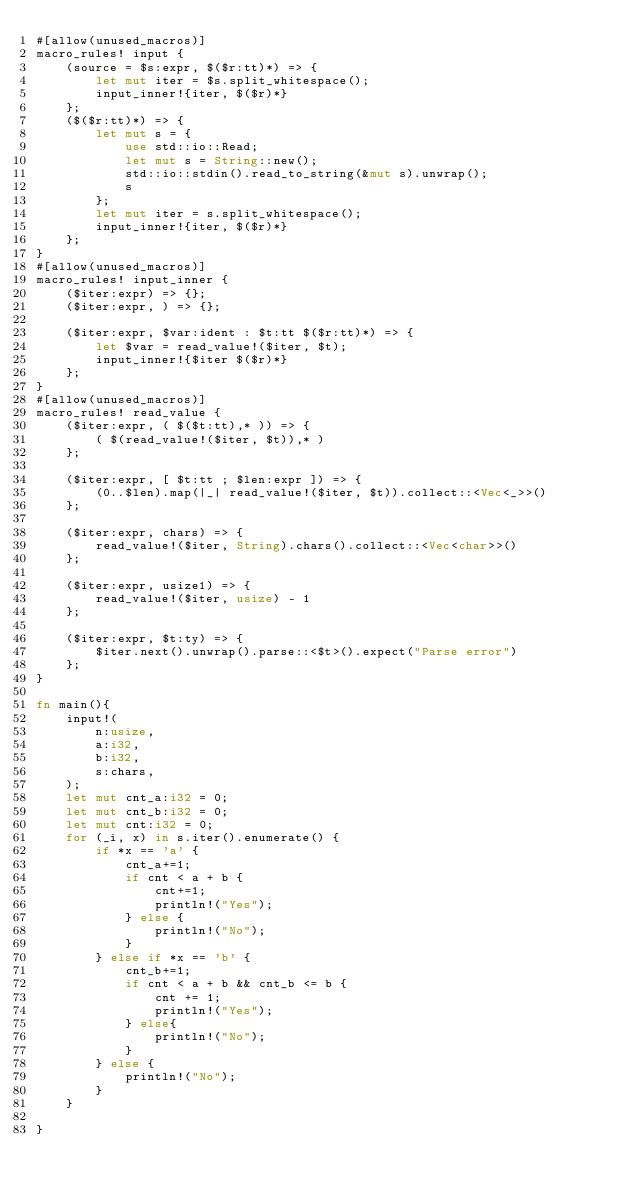<code> <loc_0><loc_0><loc_500><loc_500><_Rust_>#[allow(unused_macros)]
macro_rules! input {
    (source = $s:expr, $($r:tt)*) => {
        let mut iter = $s.split_whitespace();
        input_inner!{iter, $($r)*}
    };
    ($($r:tt)*) => {
        let mut s = {
            use std::io::Read;
            let mut s = String::new();
            std::io::stdin().read_to_string(&mut s).unwrap();
            s
        };
        let mut iter = s.split_whitespace();
        input_inner!{iter, $($r)*}
    };
}
#[allow(unused_macros)]
macro_rules! input_inner {
    ($iter:expr) => {};
    ($iter:expr, ) => {};

    ($iter:expr, $var:ident : $t:tt $($r:tt)*) => {
        let $var = read_value!($iter, $t);
        input_inner!{$iter $($r)*}
    };
}
#[allow(unused_macros)]
macro_rules! read_value {
    ($iter:expr, ( $($t:tt),* )) => {
        ( $(read_value!($iter, $t)),* )
    };

    ($iter:expr, [ $t:tt ; $len:expr ]) => {
        (0..$len).map(|_| read_value!($iter, $t)).collect::<Vec<_>>()
    };

    ($iter:expr, chars) => {
        read_value!($iter, String).chars().collect::<Vec<char>>()
    };

    ($iter:expr, usize1) => {
        read_value!($iter, usize) - 1
    };

    ($iter:expr, $t:ty) => {
        $iter.next().unwrap().parse::<$t>().expect("Parse error")
    };
}

fn main(){
    input!(
        n:usize, 
        a:i32, 
        b:i32,
        s:chars,
    );
    let mut cnt_a:i32 = 0;
    let mut cnt_b:i32 = 0;
    let mut cnt:i32 = 0;
    for (_i, x) in s.iter().enumerate() {
        if *x == 'a' {
            cnt_a+=1;
            if cnt < a + b {
                cnt+=1;
                println!("Yes");
            } else {
                println!("No");
            }
        } else if *x == 'b' {
            cnt_b+=1;
            if cnt < a + b && cnt_b <= b {
                cnt += 1;
                println!("Yes");
            } else{
                println!("No");
            }
        } else {
            println!("No");
        }
    }
 
}</code> 